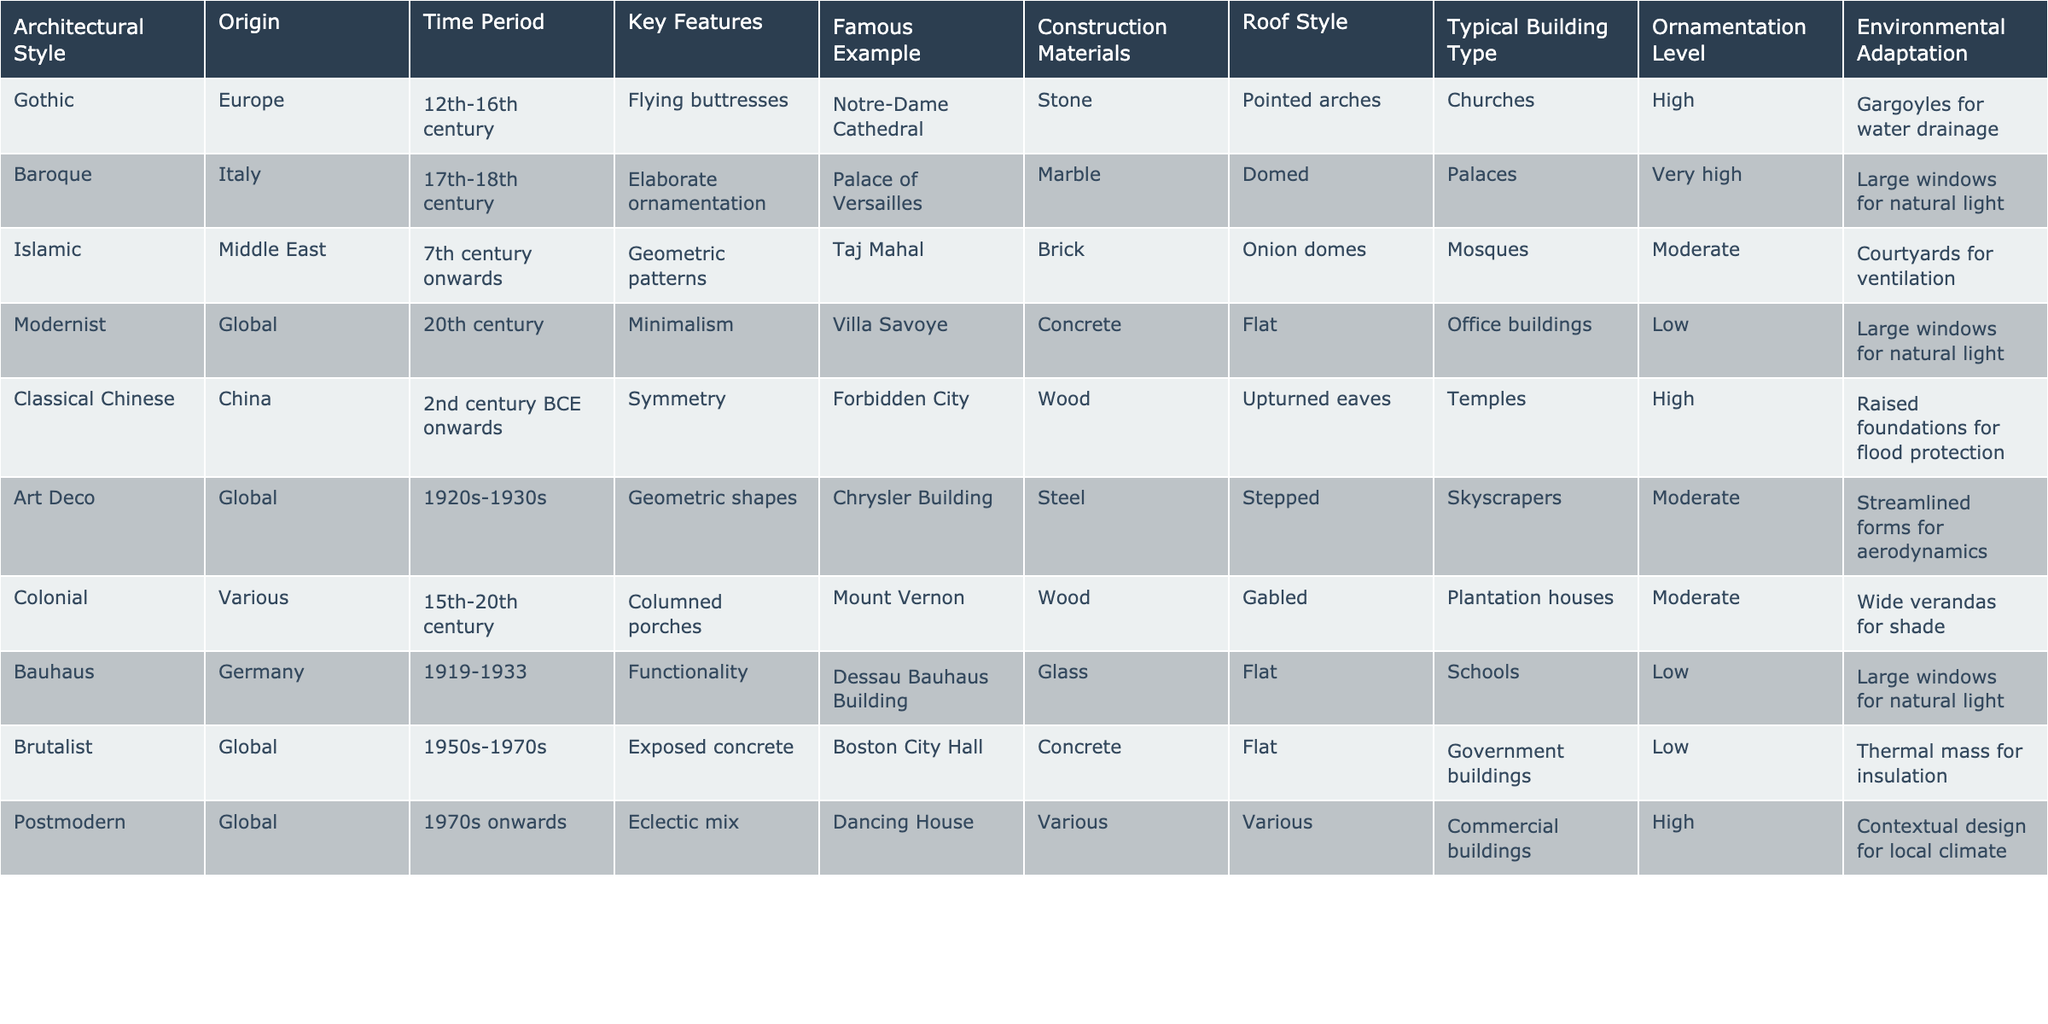What is the origin of the Baroque architectural style? The table lists the origin of each architectural style, and for Baroque, it shows "Italy."
Answer: Italy Which architectural style features flying buttresses? By looking at the "Key Features" column, the style associated with flying buttresses is Gothic.
Answer: Gothic How many architectural styles originated in the Middle East? By checking the "Origin" column, only one style listed originates in the Middle East, which is the Islamic style.
Answer: One Which architectural style is characterized by minimalism? The table indicates that the Modernist style is characterized by minimalism in the "Key Features" column.
Answer: Modernist Is the Taj Mahal a famous example of Gothic architecture? The table shows that the Taj Mahal is listed under the Islamic architectural style, not Gothic, so this statement is false.
Answer: No What construction materials are commonly used in Brutalist architecture? The "Construction Materials" column indicates that Brutalist architecture commonly uses concrete.
Answer: Concrete Identify the roof style associated with Classical Chinese architecture. From the "Roof Style" column in the table, the Classical Chinese architecture features upturned eaves as its roof style.
Answer: Upturned eaves What is the key feature that distinguishes Postmodern architecture? The table highlights that the Postmodern style is known for its eclectic mix, found in the "Key Features" column.
Answer: Eclectic mix In which time period did the Colonial architectural style predominantly develop? According to the "Time Period" column, the Colonial architectural style developed from the 15th to the 20th century.
Answer: 15th-20th century Which architectural style is known to have a very high level of ornamentation? Referring to the "Ornamentation Level" column, Baroque architecture is known for having a very high level of ornamentation.
Answer: Baroque Was the Dancing House built before the 1970s? The time period for Postmodern architecture in the table states it began in the 1970s, so it was not built before this time.
Answer: No What architectural styles utilize large windows for natural light? By examining the "Key Features," both Modernist and Baroque styles mention large windows for natural light, indicating two styles utilize this feature.
Answer: Two How does the ornamentation level of Art Deco compare to Modernist architecture? The table shows that Art Deco has a moderate level of ornamentation, while Modernist architecture has a low level. Thus, Art Deco has a higher level of ornamentation than Modernist.
Answer: Higher What is the most common roof style found in Islamic architecture based on the table? The "Roof Style" column indicates that Islamic architecture typically features onion domes.
Answer: Onion domes Which styles use concrete as a construction material? The "Construction Materials" column lists Brutalist and Modernist architectural styles as both using concrete.
Answer: Two styles 